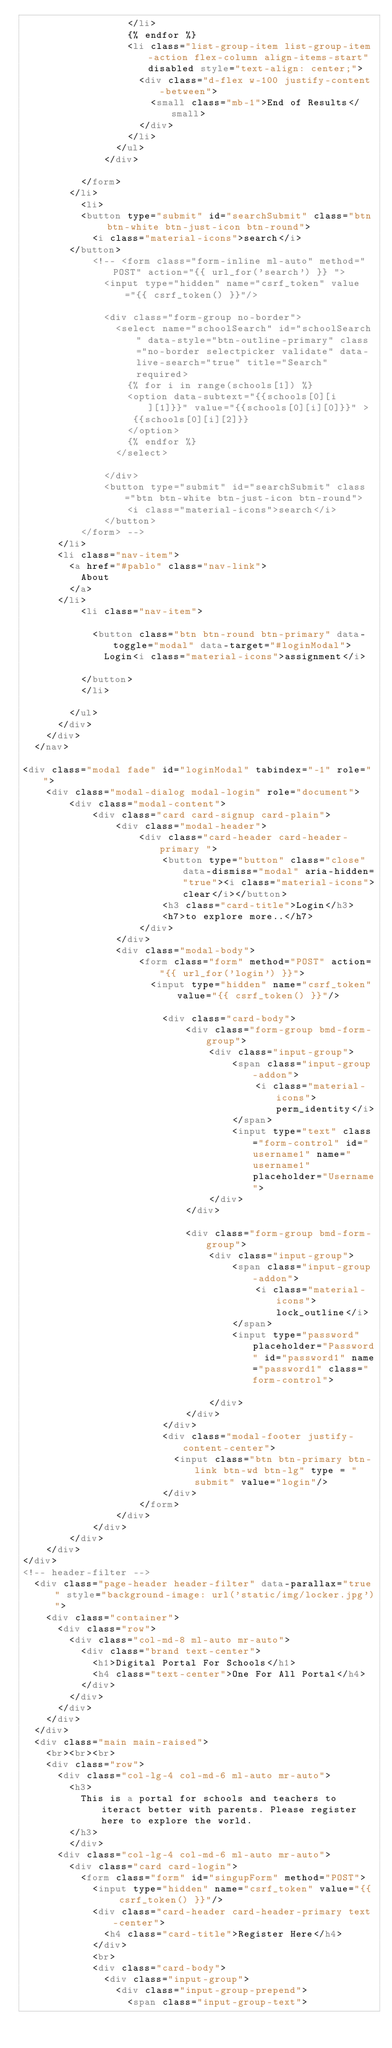Convert code to text. <code><loc_0><loc_0><loc_500><loc_500><_HTML_>                  </li>
                  {% endfor %}
                  <li class="list-group-item list-group-item-action flex-column align-items-start" disabled style="text-align: center;">
                    <div class="d-flex w-100 justify-content-between">
                      <small class="mb-1">End of Results</small>
                    </div>
                  </li>
                </ul>
              </div>
              
          </form>
        </li>
          <li>
          <button type="submit" id="searchSubmit" class="btn btn-white btn-just-icon btn-round">
            <i class="material-icons">search</i>
        </button>
            <!-- <form class="form-inline ml-auto" method="POST" action="{{ url_for('search') }} ">
              <input type="hidden" name="csrf_token" value="{{ csrf_token() }}"/>
            
              <div class="form-group no-border">
                <select name="schoolSearch" id="schoolSearch" data-style="btn-outline-primary" class="no-border selectpicker validate" data-live-search="true" title="Search" required>
                  {% for i in range(schools[1]) %}
                  <option data-subtext="{{schools[0][i][1]}}" value="{{schools[0][i][0]}}" >
                   {{schools[0][i][2]}}
                  </option>
                  {% endfor %}
                </select>
              
              </div>
              <button type="submit" id="searchSubmit" class="btn btn-white btn-just-icon btn-round">
                  <i class="material-icons">search</i>
              </button>
          </form> -->
      </li>
      <li class="nav-item">
        <a href="#pablo" class="nav-link">
          About
        </a>
      </li>
          <li class="nav-item">
            
            <button class="btn btn-round btn-primary" data-toggle="modal" data-target="#loginModal">
              Login<i class="material-icons">assignment</i>
          
          </button>
          </li>
          
        </ul>
      </div>
    </div>
  </nav>

<div class="modal fade" id="loginModal" tabindex="-1" role="">
    <div class="modal-dialog modal-login" role="document">
        <div class="modal-content">
            <div class="card card-signup card-plain">
                <div class="modal-header">
                    <div class="card-header card-header-primary ">
                        <button type="button" class="close" data-dismiss="modal" aria-hidden="true"><i class="material-icons">clear</i></button>
                        <h3 class="card-title">Login</h3>
                        <h7>to explore more..</h7>
                    </div>
                </div>
                <div class="modal-body">
                    <form class="form" method="POST" action="{{ url_for('login') }}">
                      <input type="hidden" name="csrf_token" value="{{ csrf_token() }}"/>
            
                        <div class="card-body">
                            <div class="form-group bmd-form-group">
                                <div class="input-group">
                                    <span class="input-group-addon">
                                        <i class="material-icons">perm_identity</i>
                                    </span>
                                    <input type="text" class="form-control" id="username1" name="username1" placeholder="Username">
                                </div>
                            </div>

                            <div class="form-group bmd-form-group">
                                <div class="input-group">
                                    <span class="input-group-addon">
                                        <i class="material-icons">lock_outline</i>
                                    </span>
                                    <input type="password" placeholder="Password" id="password1" name="password1" class="form-control">
                                    
                                </div>
                            </div>
                        </div>
                        <div class="modal-footer justify-content-center">
                          <input class="btn btn-primary btn-link btn-wd btn-lg" type = "submit" value="login"/>
                        </div>
                    </form>
                </div>
            </div>
        </div>
    </div>
</div>
<!-- header-filter -->
  <div class="page-header header-filter" data-parallax="true" style="background-image: url('static/img/locker.jpg')">
    <div class="container">
      <div class="row">
        <div class="col-md-8 ml-auto mr-auto">
          <div class="brand text-center">
            <h1>Digital Portal For Schools</h1>
            <h4 class="text-center">One For All Portal</h4>
          </div>
        </div>
      </div>
    </div>
  </div>
  <div class="main main-raised">
    <br><br><br>
    <div class="row">
      <div class="col-lg-4 col-md-6 ml-auto mr-auto">
        <h3>
          This is a portal for schools and teachers to iteract better with parents. Please register here to explore the world. 
        </h3>
        </div>
      <div class="col-lg-4 col-md-6 ml-auto mr-auto">
        <div class="card card-login">
          <form class="form" id="singupForm" method="POST">
            <input type="hidden" name="csrf_token" value="{{ csrf_token() }}"/>
            <div class="card-header card-header-primary text-center">
              <h4 class="card-title">Register Here</h4>
            </div>
            <br>
            <div class="card-body">
              <div class="input-group">
                <div class="input-group-prepend">
                  <span class="input-group-text"></code> 